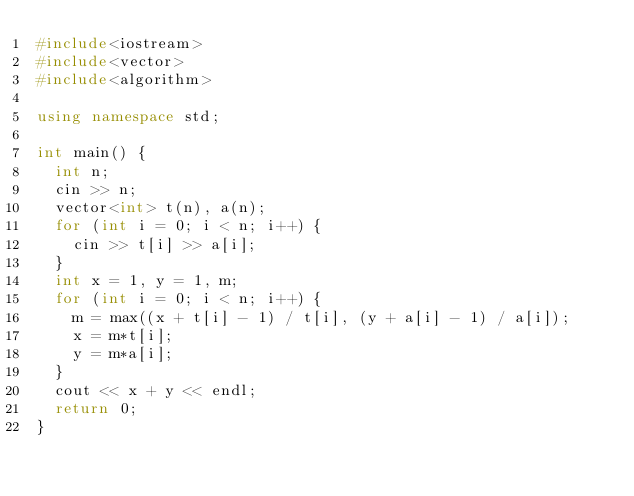<code> <loc_0><loc_0><loc_500><loc_500><_C++_>#include<iostream>
#include<vector>
#include<algorithm>

using namespace std;

int main() {
	int n;
	cin >> n;
	vector<int> t(n), a(n);
	for (int i = 0; i < n; i++) {
		cin >> t[i] >> a[i];
	}
	int x = 1, y = 1, m;
	for (int i = 0; i < n; i++) {
		m = max((x + t[i] - 1) / t[i], (y + a[i] - 1) / a[i]);
		x = m*t[i];
		y = m*a[i];
	}
	cout << x + y << endl;
	return 0;
}</code> 